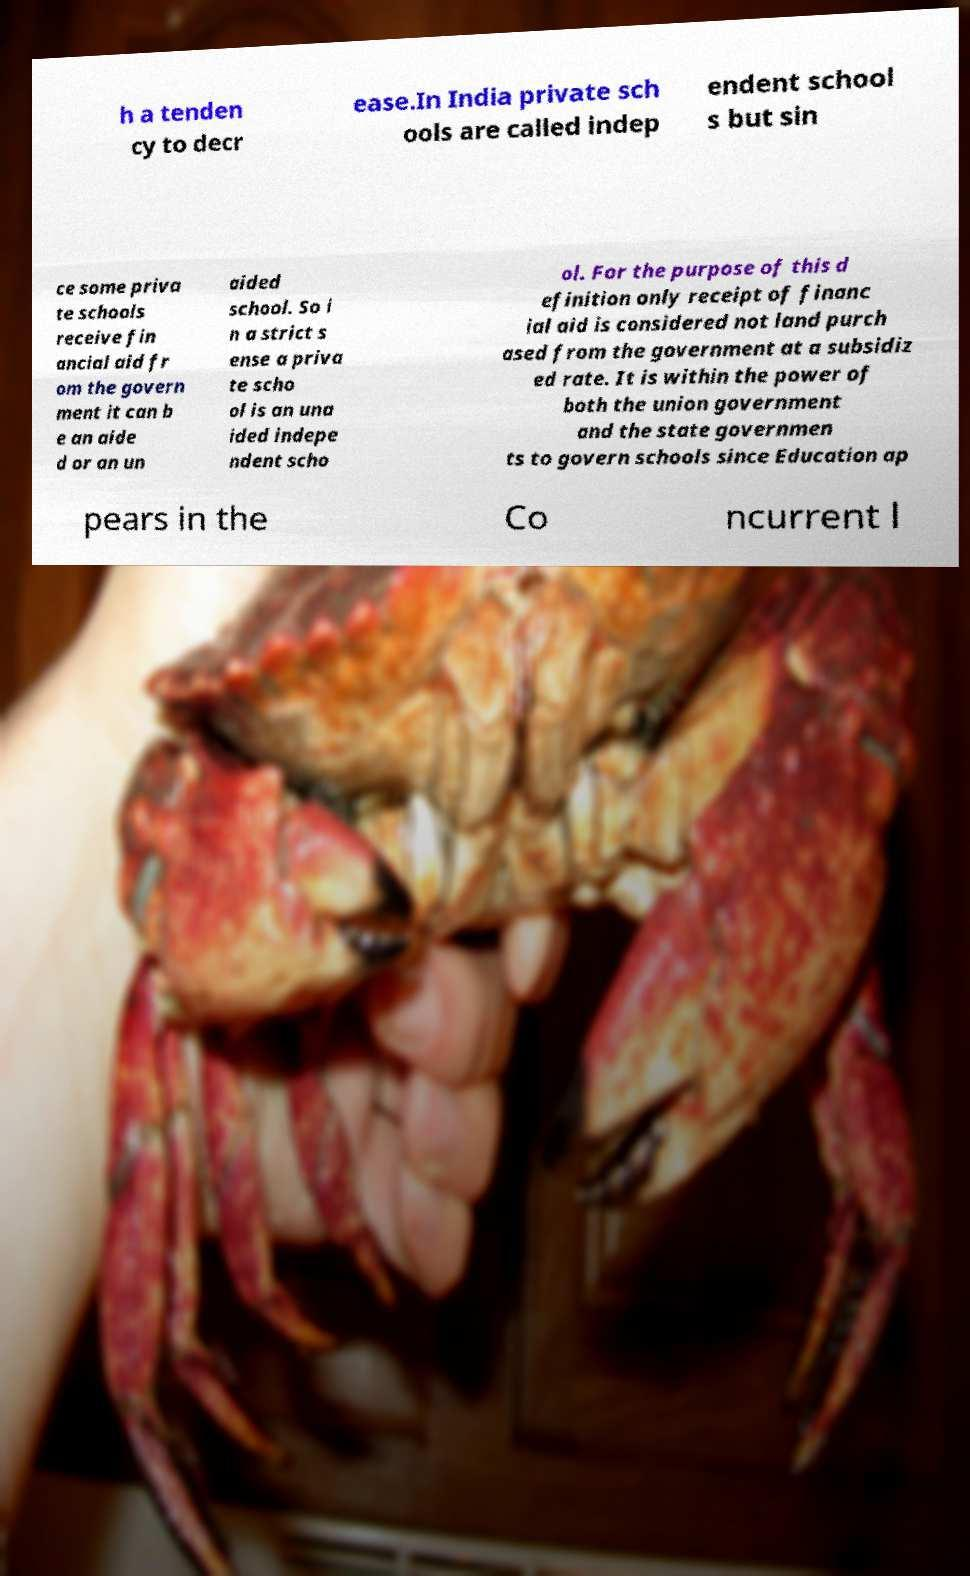Could you assist in decoding the text presented in this image and type it out clearly? h a tenden cy to decr ease.In India private sch ools are called indep endent school s but sin ce some priva te schools receive fin ancial aid fr om the govern ment it can b e an aide d or an un aided school. So i n a strict s ense a priva te scho ol is an una ided indepe ndent scho ol. For the purpose of this d efinition only receipt of financ ial aid is considered not land purch ased from the government at a subsidiz ed rate. It is within the power of both the union government and the state governmen ts to govern schools since Education ap pears in the Co ncurrent l 